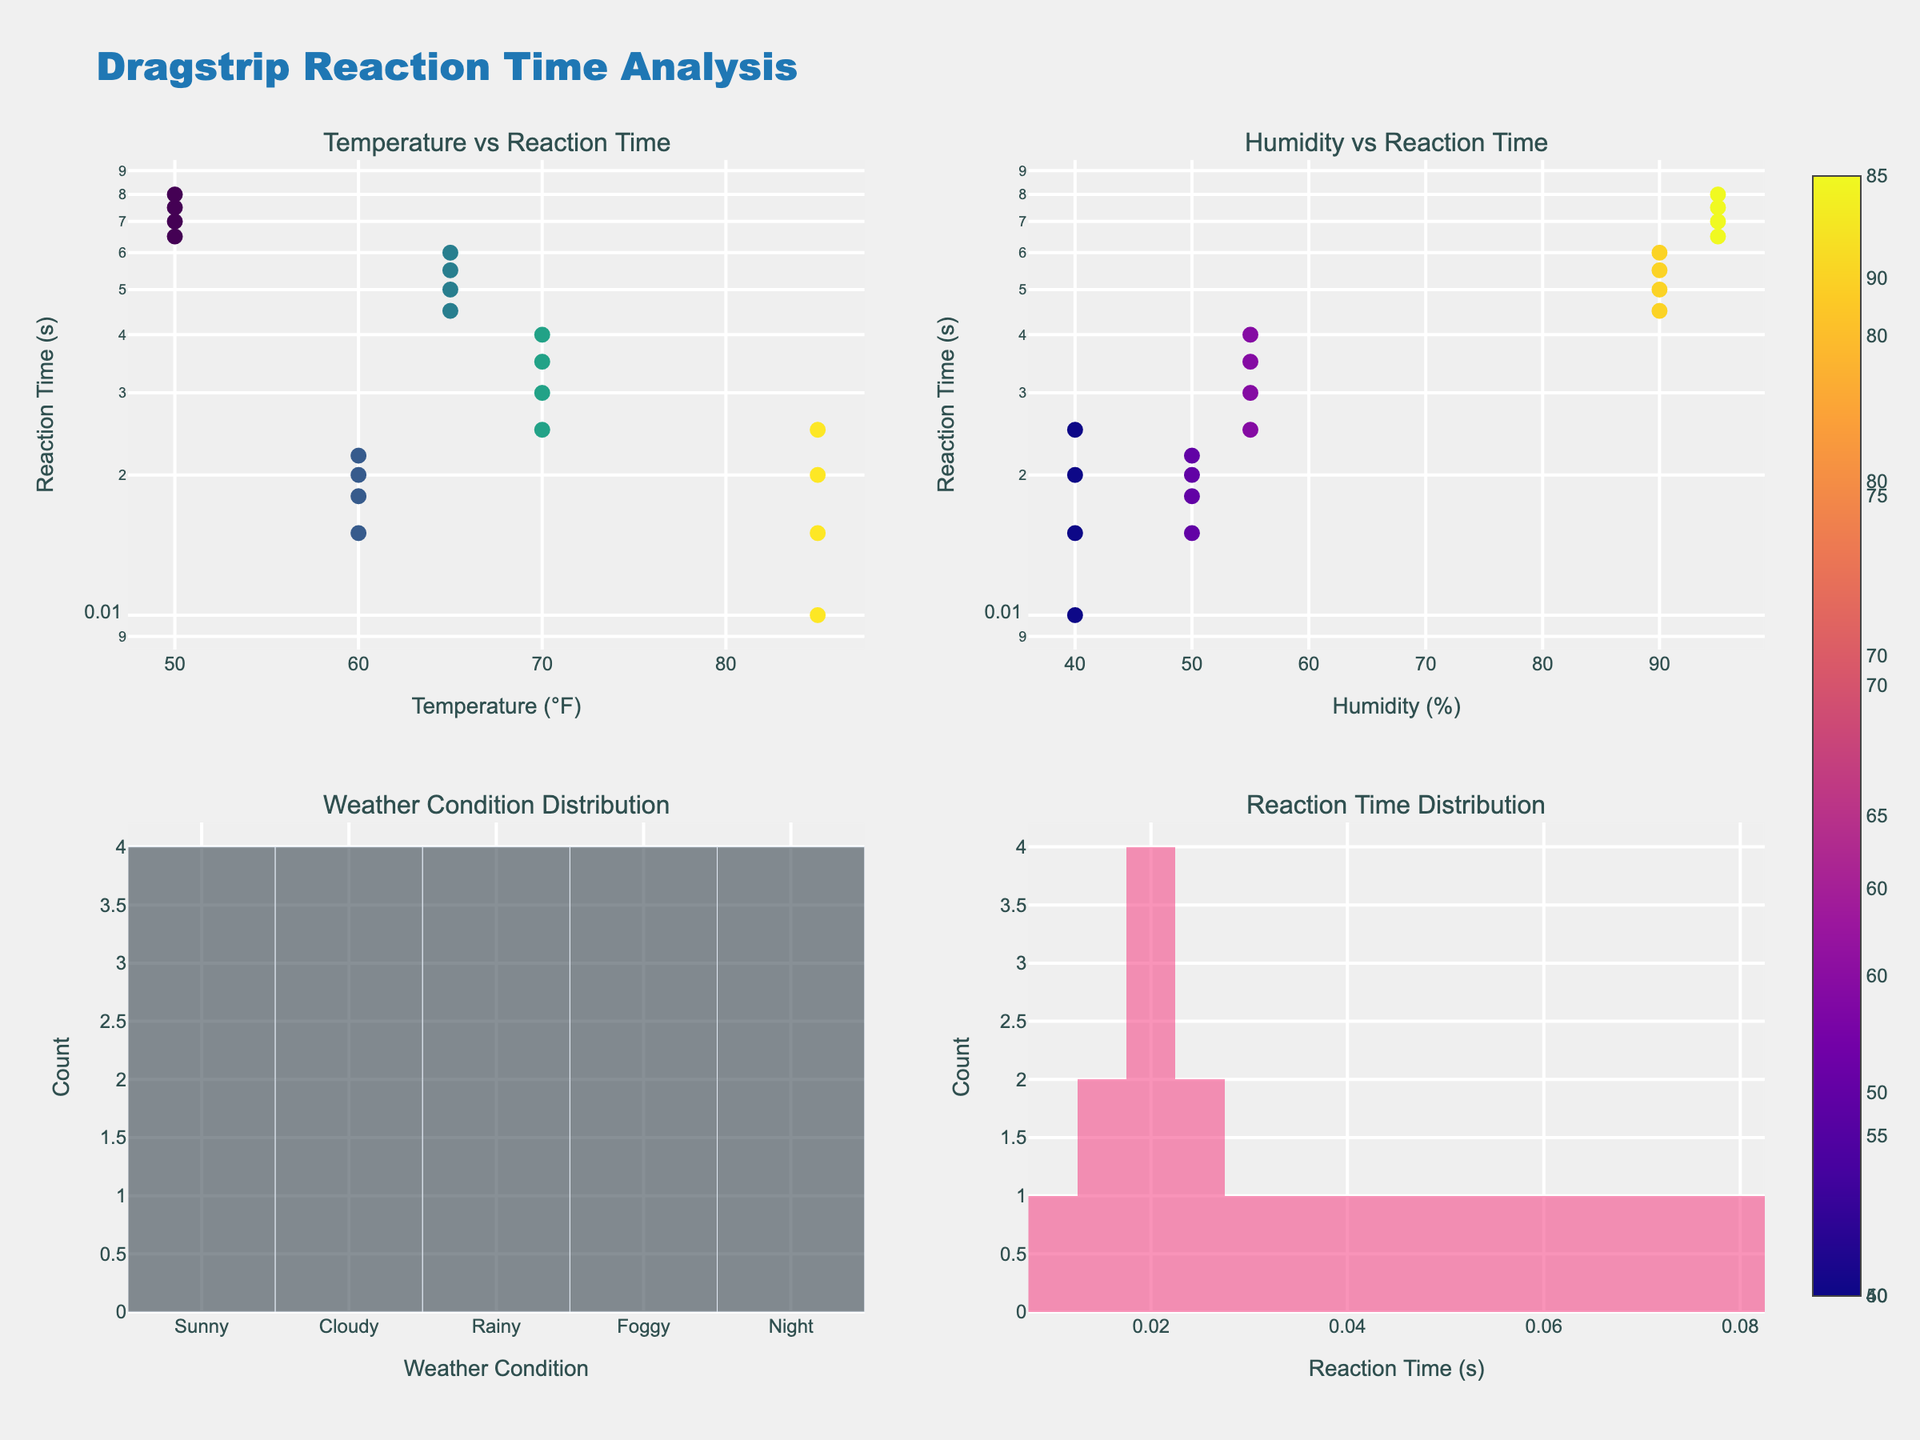What is the title of the overall plot? The title is displayed prominently at the top center of the figure, indicating the overarching theme of the analysis.
Answer: Dragstrip Reaction Time Analysis Which weather condition has the most data points? The bar plot in the bottom left subplot shows the distribution of entries across different weather conditions. The tallest bar corresponds to the 'Sunny' condition.
Answer: Sunny What is the shape of the Temperature vs. Reaction Time plot? The top left subplot shows data points scattered across the log scale, indicating the relationship between temperature and reaction time.
Answer: Scatter plot What is the log scale used in the Reaction Time Distribution? The y-axis of the Reaction Time Distribution plot in the top subplots uses a log scale, which is indicated by the axis labeling.
Answer: Log scale How does the Reaction Time respond to increased humidity in the plot? The top right subplot shows the relationship between humidity and reaction time on a scatter plot. Most data points are clustered together with an uptick in reaction time for higher humidity.
Answer: Reaction time increases with humidity In which weather condition is the longest reaction time observed? By examining the top left and right subplots, you can see that the highest reaction times are associated with the 'Foggy' condition.
Answer: Foggy Compare the range of reaction times between 'Sunny' and 'Rainy' conditions. 'Sunny' condition reaction times range between 0.010 and 0.025 seconds, while 'Rainy' condition reaction times range between 0.045 and 0.060 seconds. This comparison involves identifying and comparing the minimum and maximum values in each condition.
Answer: Sunny: 0.010-0.025, Rainy: 0.045-0.060 What type of visual representation is used for the Reaction Time Distribution? The bottom right subplot uses a histogram to represent the distribution of reaction times across different bins.
Answer: Histogram Which subplot helps in understanding the frequency of each weather condition in the dataset? The bottom left subplot uses a bar chart to display the counts of entries per weather condition, making it easy to gauge their frequencies.
Answer: Weather Condition Distribution plot 